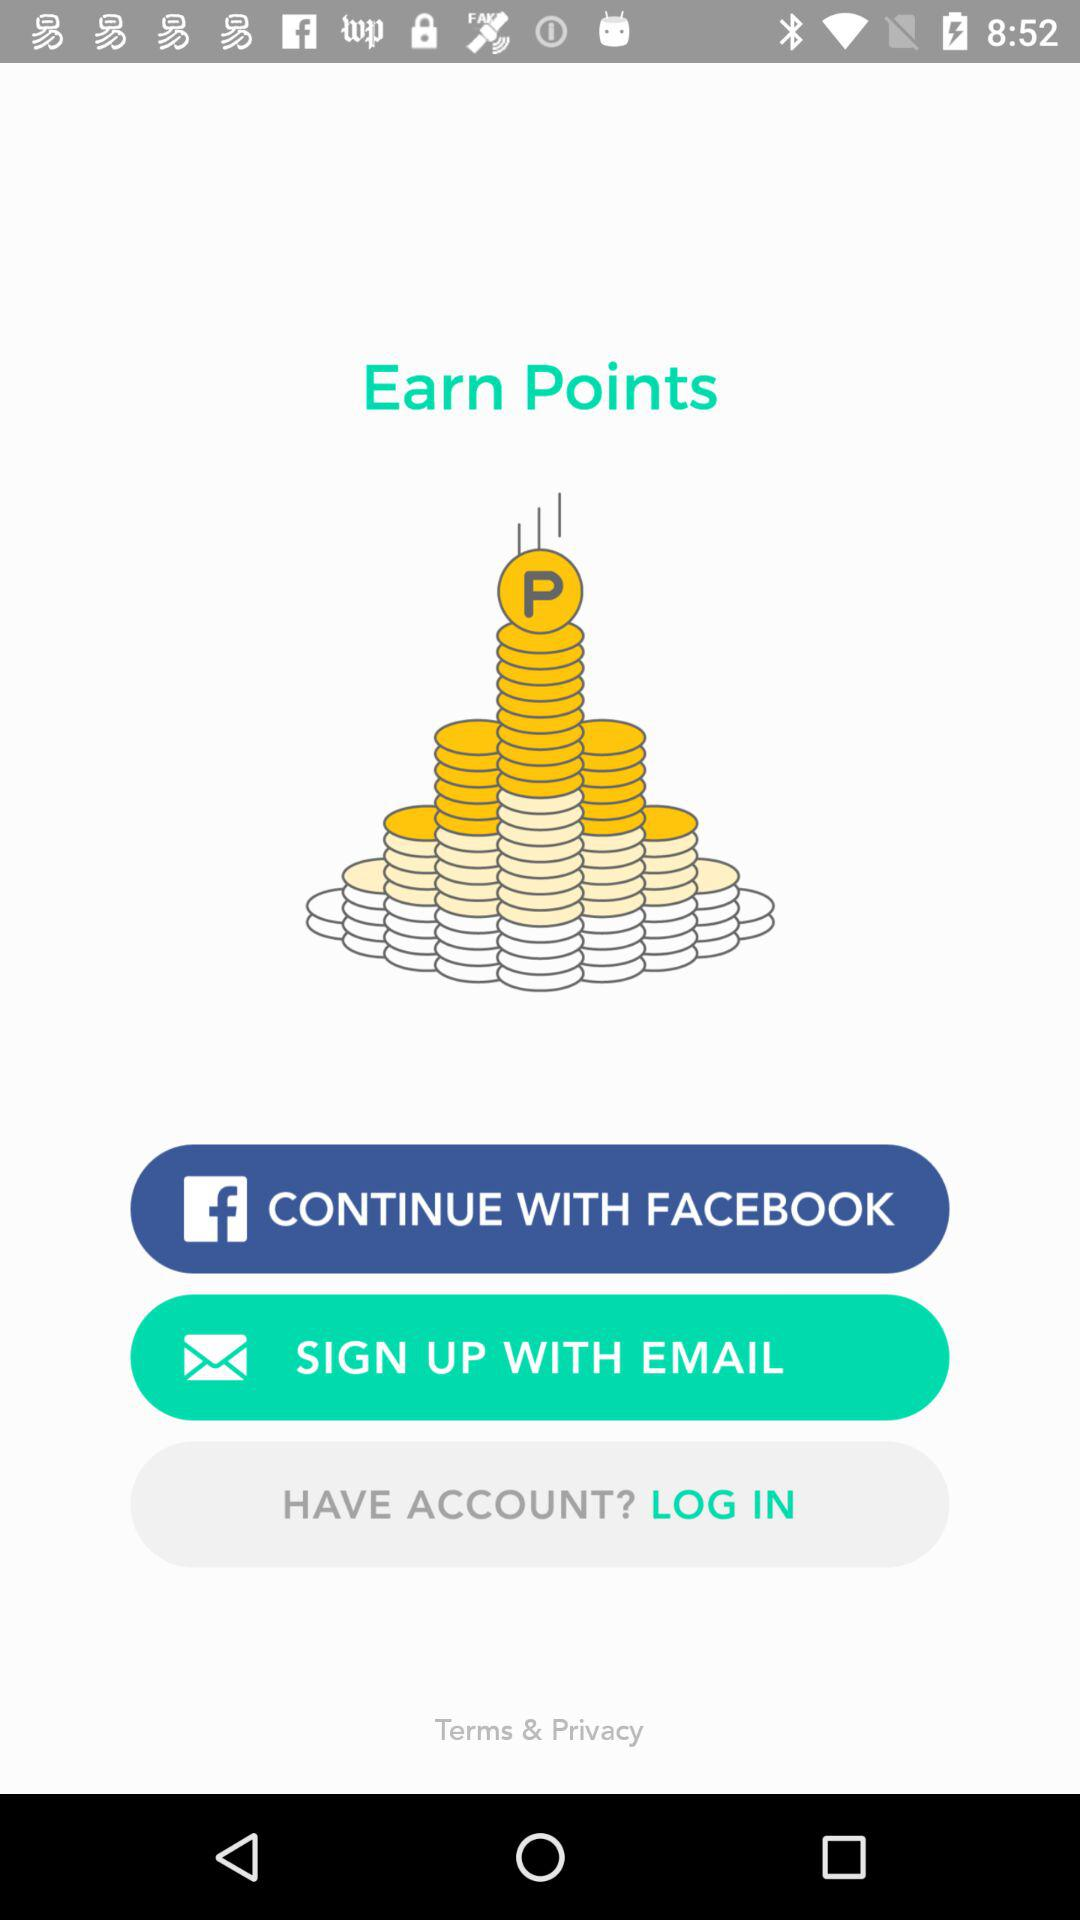What is the option to sign up? The option to sign up is "EMAIL". 